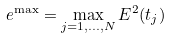<formula> <loc_0><loc_0><loc_500><loc_500>e ^ { \max } = \max _ { j = 1 , \dots , N } E ^ { 2 } ( t _ { j } )</formula> 